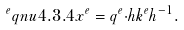Convert formula to latex. <formula><loc_0><loc_0><loc_500><loc_500>^ { e } q n u { 4 . 3 . 4 } x ^ { e } = q ^ { e } { \cdot } h k ^ { e } h ^ { - 1 } .</formula> 